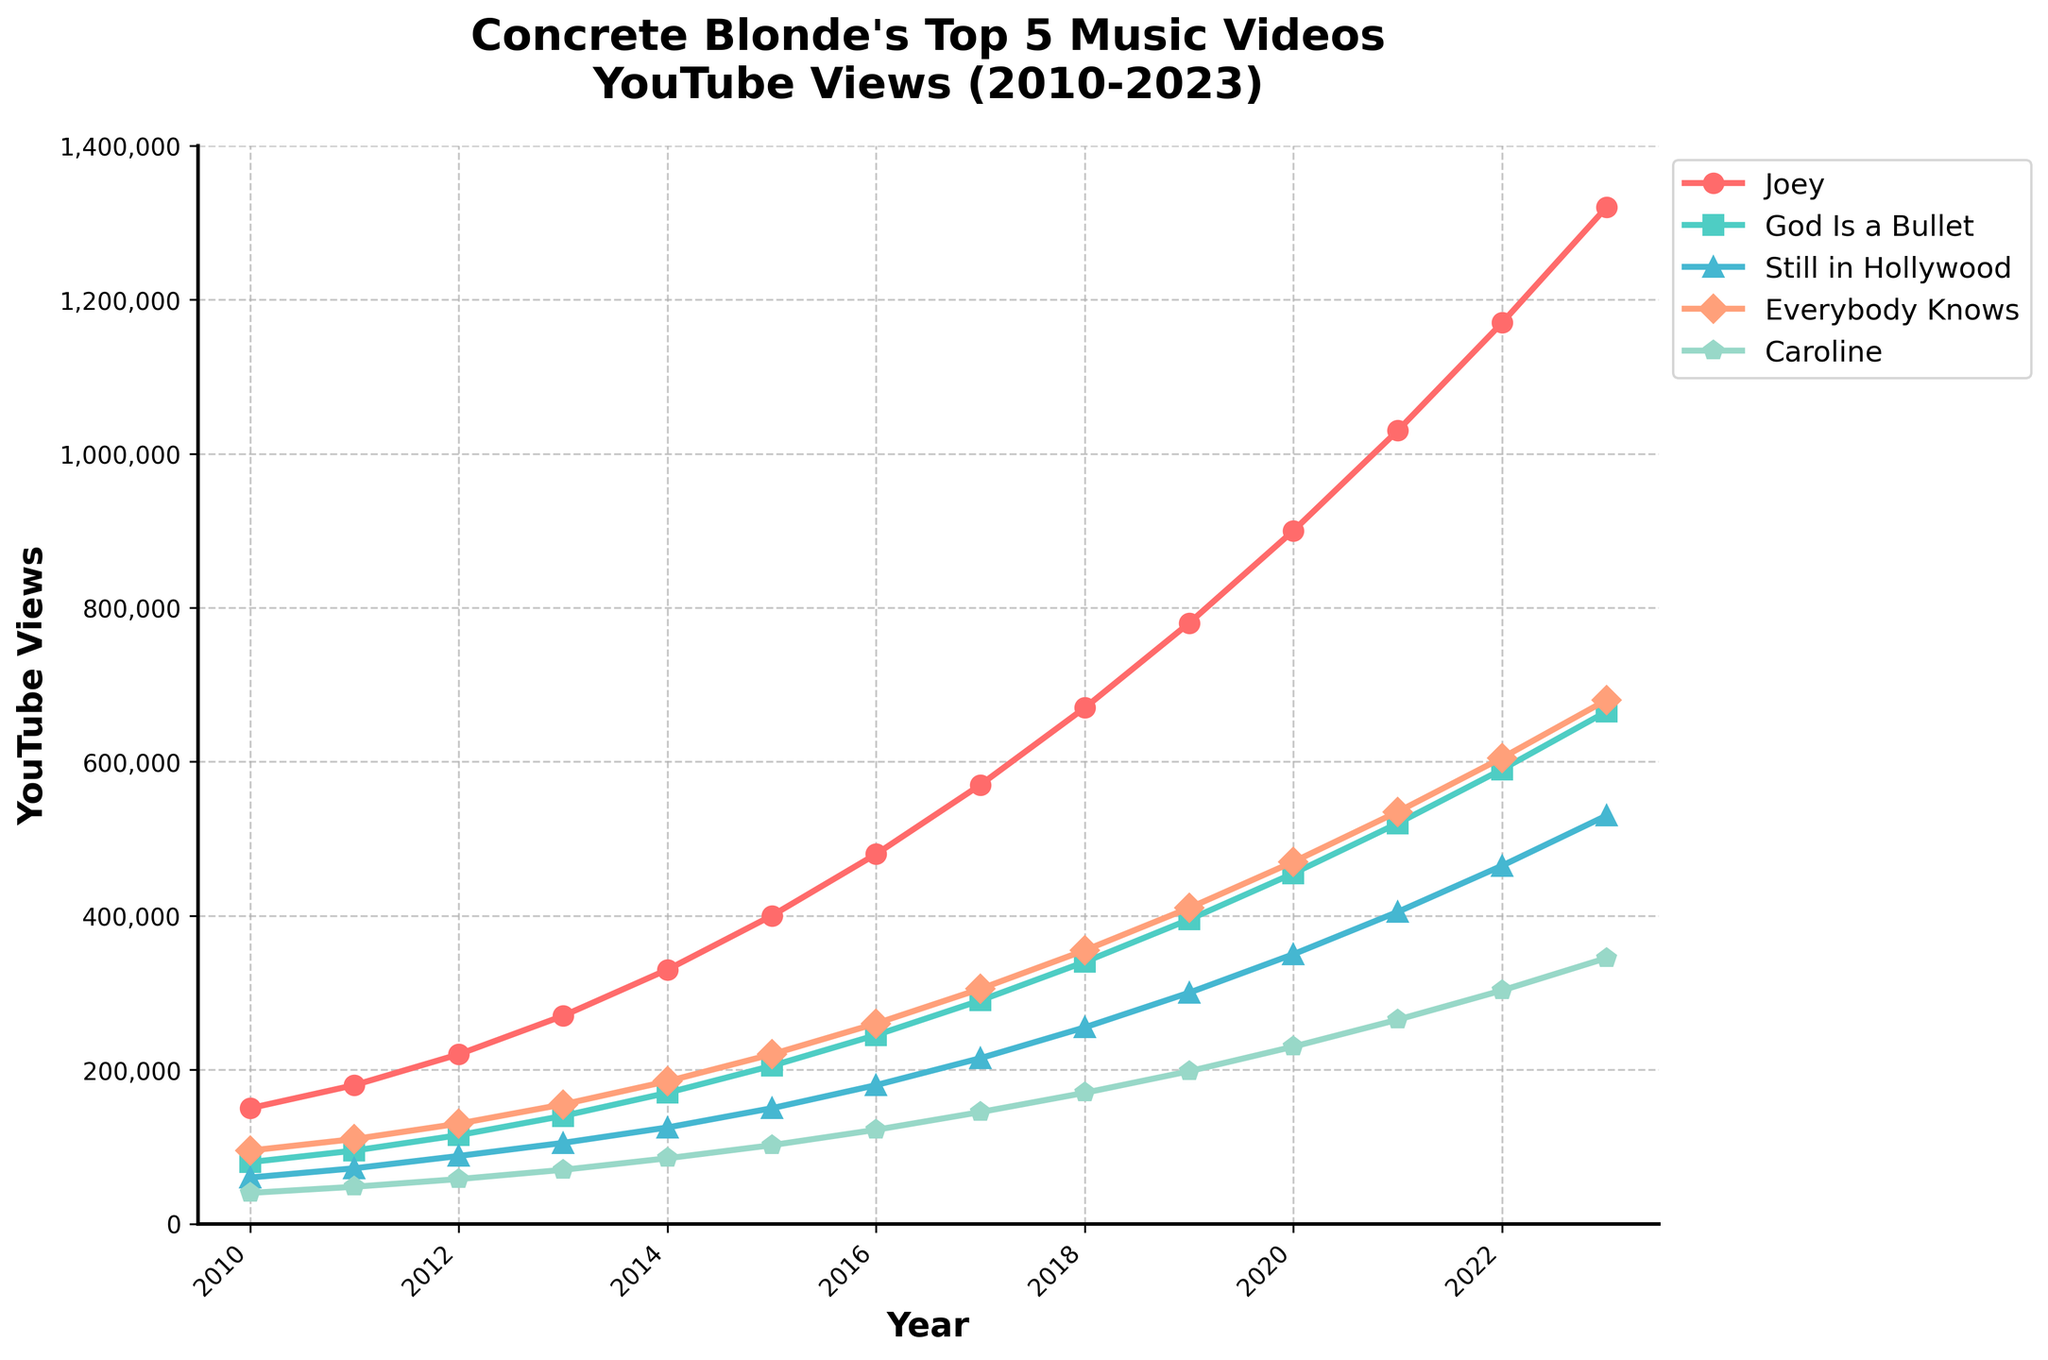Which music video has the highest view count in 2023? To find this, look at the lines at the end of the plot for the year 2023. The line for "Joey" is the highest. "Joey" has the highest view count in 2023.
Answer: Joey In which year did "God Is a Bullet" overtake "Still in Hollywood" in views? Examine the intersection points of the lines "God Is a Bullet" and "Still in Hollywood". "God Is a Bullet" overtook "Still in Hollywood" in 2011.
Answer: 2011 How many total views did the videos "Joey" and "Everybody Knows" have in 2016? Add the number of views for "Joey" and "Everybody Knows" in 2016. Joey had 480,000 and Everybody Knows had 260,000. So, 480,000 + 260,000 = 740,000.
Answer: 740,000 Which video had the steepest increase in views between 2010 and 2023? Measure the slope of the lines from 2010 to 2023. "Joey" has the steepest slope since it increased the most.
Answer: Joey What is the average number of views for "Caroline" from 2010 to 2023? Sum the yearly views from 2010 to 2023 and divide by the number of years. (40,000 + 48,000 + 58,000 + 70,000 + 85,000 + 102,000 + 122,000 + 145,000 + 170,000 + 198,000 + 230,000 + 265,000 + 303,000 + 345,000) / 14 = 1,981,000 / 14 = 141,500.
Answer: 141,500 In which year did "Everybody Knows" first surpass 500,000 views? Find "Everybody Knows" in the plot and locate the year where it crossed 500,000 views. It crossed 500,000 views in 2021.
Answer: 2021 Which video had the lowest view count in 2015? Look at the values for all videos in 2015. "Caroline" had the lowest count of 102,000.
Answer: Caroline What is the difference in view counts between "Joey" and "God Is a Bullet" in 2023? Subtract the 2023 view count of "God Is a Bullet" from that of "Joey". 1,320,000 - 665,000 = 655,000.
Answer: 655,000 How many years did it take for "God Is a Bullet" to go from 100,000 to 500,000 views? Find when "God Is a Bullet" first hit 100,000 and 500,000 views. It crossed 100,000 views in 2012 and crossed 500,000 in 2021, so it took 9 years.
Answer: 9 Which music video had the second steepest growth rate from 2010 to 2023? Compare the slopes of the lines visually, considering the steepest slope already determined as "Joey". "Everybody Knows" appears to have the second steepest slope.
Answer: Everybody Knows 